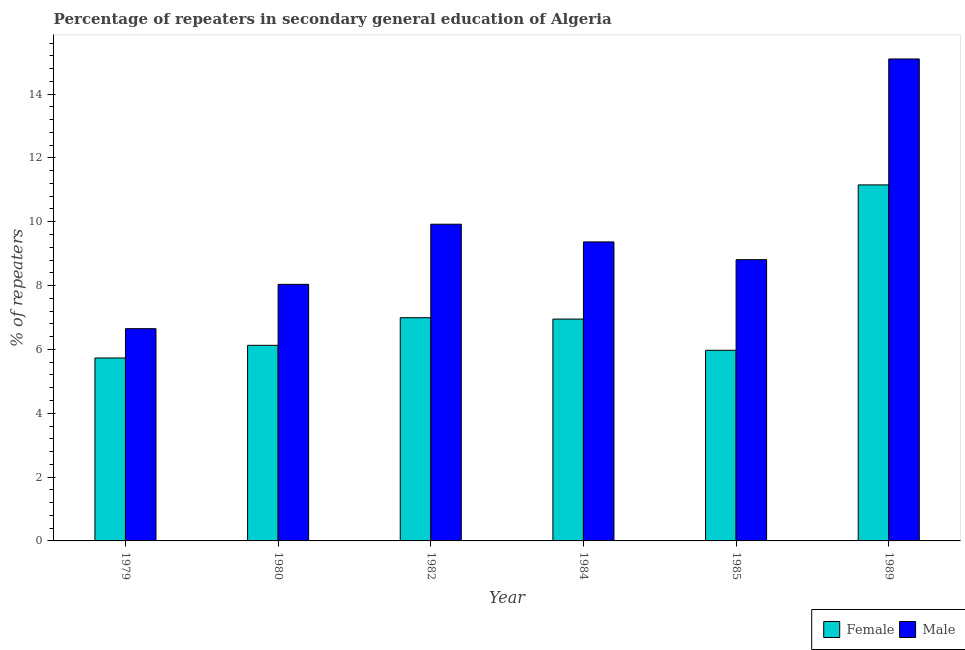How many different coloured bars are there?
Your response must be concise. 2. How many groups of bars are there?
Your answer should be compact. 6. How many bars are there on the 1st tick from the right?
Your response must be concise. 2. What is the label of the 1st group of bars from the left?
Keep it short and to the point. 1979. In how many cases, is the number of bars for a given year not equal to the number of legend labels?
Provide a short and direct response. 0. What is the percentage of female repeaters in 1979?
Provide a succinct answer. 5.73. Across all years, what is the maximum percentage of male repeaters?
Keep it short and to the point. 15.1. Across all years, what is the minimum percentage of female repeaters?
Give a very brief answer. 5.73. In which year was the percentage of female repeaters maximum?
Give a very brief answer. 1989. In which year was the percentage of female repeaters minimum?
Your response must be concise. 1979. What is the total percentage of male repeaters in the graph?
Give a very brief answer. 57.89. What is the difference between the percentage of female repeaters in 1979 and that in 1982?
Keep it short and to the point. -1.26. What is the difference between the percentage of female repeaters in 1984 and the percentage of male repeaters in 1985?
Offer a terse response. 0.98. What is the average percentage of male repeaters per year?
Provide a succinct answer. 9.65. In how many years, is the percentage of male repeaters greater than 8 %?
Give a very brief answer. 5. What is the ratio of the percentage of female repeaters in 1980 to that in 1985?
Your answer should be very brief. 1.03. What is the difference between the highest and the second highest percentage of female repeaters?
Your answer should be very brief. 4.16. What is the difference between the highest and the lowest percentage of male repeaters?
Your answer should be compact. 8.45. Is the sum of the percentage of male repeaters in 1980 and 1982 greater than the maximum percentage of female repeaters across all years?
Keep it short and to the point. Yes. What does the 1st bar from the right in 1985 represents?
Make the answer very short. Male. How many bars are there?
Offer a very short reply. 12. Are all the bars in the graph horizontal?
Your answer should be very brief. No. What is the title of the graph?
Keep it short and to the point. Percentage of repeaters in secondary general education of Algeria. What is the label or title of the X-axis?
Your answer should be very brief. Year. What is the label or title of the Y-axis?
Offer a very short reply. % of repeaters. What is the % of repeaters of Female in 1979?
Offer a terse response. 5.73. What is the % of repeaters in Male in 1979?
Provide a short and direct response. 6.65. What is the % of repeaters in Female in 1980?
Your response must be concise. 6.13. What is the % of repeaters in Male in 1980?
Your answer should be compact. 8.04. What is the % of repeaters in Female in 1982?
Offer a very short reply. 6.99. What is the % of repeaters of Male in 1982?
Provide a short and direct response. 9.92. What is the % of repeaters in Female in 1984?
Give a very brief answer. 6.95. What is the % of repeaters in Male in 1984?
Keep it short and to the point. 9.37. What is the % of repeaters of Female in 1985?
Provide a succinct answer. 5.97. What is the % of repeaters of Male in 1985?
Ensure brevity in your answer.  8.81. What is the % of repeaters of Female in 1989?
Your answer should be compact. 11.15. What is the % of repeaters in Male in 1989?
Your answer should be very brief. 15.1. Across all years, what is the maximum % of repeaters of Female?
Offer a very short reply. 11.15. Across all years, what is the maximum % of repeaters of Male?
Your answer should be compact. 15.1. Across all years, what is the minimum % of repeaters of Female?
Offer a terse response. 5.73. Across all years, what is the minimum % of repeaters of Male?
Your answer should be compact. 6.65. What is the total % of repeaters of Female in the graph?
Make the answer very short. 42.93. What is the total % of repeaters in Male in the graph?
Keep it short and to the point. 57.89. What is the difference between the % of repeaters of Female in 1979 and that in 1980?
Give a very brief answer. -0.4. What is the difference between the % of repeaters in Male in 1979 and that in 1980?
Offer a terse response. -1.39. What is the difference between the % of repeaters of Female in 1979 and that in 1982?
Ensure brevity in your answer.  -1.26. What is the difference between the % of repeaters in Male in 1979 and that in 1982?
Keep it short and to the point. -3.27. What is the difference between the % of repeaters in Female in 1979 and that in 1984?
Give a very brief answer. -1.22. What is the difference between the % of repeaters of Male in 1979 and that in 1984?
Your answer should be compact. -2.72. What is the difference between the % of repeaters in Female in 1979 and that in 1985?
Offer a terse response. -0.24. What is the difference between the % of repeaters of Male in 1979 and that in 1985?
Give a very brief answer. -2.16. What is the difference between the % of repeaters in Female in 1979 and that in 1989?
Provide a short and direct response. -5.42. What is the difference between the % of repeaters in Male in 1979 and that in 1989?
Provide a short and direct response. -8.45. What is the difference between the % of repeaters in Female in 1980 and that in 1982?
Provide a succinct answer. -0.87. What is the difference between the % of repeaters of Male in 1980 and that in 1982?
Your response must be concise. -1.88. What is the difference between the % of repeaters of Female in 1980 and that in 1984?
Your answer should be very brief. -0.82. What is the difference between the % of repeaters of Male in 1980 and that in 1984?
Offer a very short reply. -1.33. What is the difference between the % of repeaters in Female in 1980 and that in 1985?
Your answer should be compact. 0.16. What is the difference between the % of repeaters in Male in 1980 and that in 1985?
Your response must be concise. -0.77. What is the difference between the % of repeaters of Female in 1980 and that in 1989?
Ensure brevity in your answer.  -5.03. What is the difference between the % of repeaters in Male in 1980 and that in 1989?
Your answer should be compact. -7.06. What is the difference between the % of repeaters in Female in 1982 and that in 1984?
Your answer should be compact. 0.04. What is the difference between the % of repeaters of Male in 1982 and that in 1984?
Make the answer very short. 0.55. What is the difference between the % of repeaters of Female in 1982 and that in 1985?
Make the answer very short. 1.02. What is the difference between the % of repeaters of Male in 1982 and that in 1985?
Provide a succinct answer. 1.11. What is the difference between the % of repeaters of Female in 1982 and that in 1989?
Keep it short and to the point. -4.16. What is the difference between the % of repeaters of Male in 1982 and that in 1989?
Offer a terse response. -5.18. What is the difference between the % of repeaters of Female in 1984 and that in 1985?
Provide a short and direct response. 0.98. What is the difference between the % of repeaters of Male in 1984 and that in 1985?
Your answer should be compact. 0.56. What is the difference between the % of repeaters in Female in 1984 and that in 1989?
Offer a very short reply. -4.2. What is the difference between the % of repeaters of Male in 1984 and that in 1989?
Offer a terse response. -5.73. What is the difference between the % of repeaters in Female in 1985 and that in 1989?
Give a very brief answer. -5.18. What is the difference between the % of repeaters in Male in 1985 and that in 1989?
Keep it short and to the point. -6.29. What is the difference between the % of repeaters in Female in 1979 and the % of repeaters in Male in 1980?
Keep it short and to the point. -2.31. What is the difference between the % of repeaters of Female in 1979 and the % of repeaters of Male in 1982?
Your answer should be very brief. -4.19. What is the difference between the % of repeaters in Female in 1979 and the % of repeaters in Male in 1984?
Provide a short and direct response. -3.64. What is the difference between the % of repeaters of Female in 1979 and the % of repeaters of Male in 1985?
Your answer should be very brief. -3.08. What is the difference between the % of repeaters of Female in 1979 and the % of repeaters of Male in 1989?
Your response must be concise. -9.37. What is the difference between the % of repeaters of Female in 1980 and the % of repeaters of Male in 1982?
Provide a succinct answer. -3.79. What is the difference between the % of repeaters in Female in 1980 and the % of repeaters in Male in 1984?
Offer a very short reply. -3.24. What is the difference between the % of repeaters in Female in 1980 and the % of repeaters in Male in 1985?
Make the answer very short. -2.68. What is the difference between the % of repeaters in Female in 1980 and the % of repeaters in Male in 1989?
Ensure brevity in your answer.  -8.97. What is the difference between the % of repeaters of Female in 1982 and the % of repeaters of Male in 1984?
Give a very brief answer. -2.37. What is the difference between the % of repeaters in Female in 1982 and the % of repeaters in Male in 1985?
Your response must be concise. -1.82. What is the difference between the % of repeaters of Female in 1982 and the % of repeaters of Male in 1989?
Provide a short and direct response. -8.11. What is the difference between the % of repeaters of Female in 1984 and the % of repeaters of Male in 1985?
Your answer should be very brief. -1.86. What is the difference between the % of repeaters in Female in 1984 and the % of repeaters in Male in 1989?
Your answer should be very brief. -8.15. What is the difference between the % of repeaters of Female in 1985 and the % of repeaters of Male in 1989?
Ensure brevity in your answer.  -9.13. What is the average % of repeaters of Female per year?
Provide a short and direct response. 7.16. What is the average % of repeaters in Male per year?
Ensure brevity in your answer.  9.65. In the year 1979, what is the difference between the % of repeaters in Female and % of repeaters in Male?
Provide a short and direct response. -0.92. In the year 1980, what is the difference between the % of repeaters in Female and % of repeaters in Male?
Give a very brief answer. -1.91. In the year 1982, what is the difference between the % of repeaters of Female and % of repeaters of Male?
Keep it short and to the point. -2.93. In the year 1984, what is the difference between the % of repeaters of Female and % of repeaters of Male?
Provide a short and direct response. -2.42. In the year 1985, what is the difference between the % of repeaters of Female and % of repeaters of Male?
Keep it short and to the point. -2.84. In the year 1989, what is the difference between the % of repeaters in Female and % of repeaters in Male?
Ensure brevity in your answer.  -3.95. What is the ratio of the % of repeaters in Female in 1979 to that in 1980?
Offer a terse response. 0.94. What is the ratio of the % of repeaters in Male in 1979 to that in 1980?
Make the answer very short. 0.83. What is the ratio of the % of repeaters in Female in 1979 to that in 1982?
Offer a very short reply. 0.82. What is the ratio of the % of repeaters in Male in 1979 to that in 1982?
Keep it short and to the point. 0.67. What is the ratio of the % of repeaters in Female in 1979 to that in 1984?
Your response must be concise. 0.82. What is the ratio of the % of repeaters in Male in 1979 to that in 1984?
Provide a succinct answer. 0.71. What is the ratio of the % of repeaters in Female in 1979 to that in 1985?
Your response must be concise. 0.96. What is the ratio of the % of repeaters in Male in 1979 to that in 1985?
Offer a very short reply. 0.75. What is the ratio of the % of repeaters of Female in 1979 to that in 1989?
Give a very brief answer. 0.51. What is the ratio of the % of repeaters in Male in 1979 to that in 1989?
Keep it short and to the point. 0.44. What is the ratio of the % of repeaters in Female in 1980 to that in 1982?
Provide a short and direct response. 0.88. What is the ratio of the % of repeaters in Male in 1980 to that in 1982?
Your answer should be very brief. 0.81. What is the ratio of the % of repeaters in Female in 1980 to that in 1984?
Give a very brief answer. 0.88. What is the ratio of the % of repeaters of Male in 1980 to that in 1984?
Your answer should be very brief. 0.86. What is the ratio of the % of repeaters in Female in 1980 to that in 1985?
Provide a succinct answer. 1.03. What is the ratio of the % of repeaters of Male in 1980 to that in 1985?
Ensure brevity in your answer.  0.91. What is the ratio of the % of repeaters in Female in 1980 to that in 1989?
Your answer should be very brief. 0.55. What is the ratio of the % of repeaters of Male in 1980 to that in 1989?
Provide a short and direct response. 0.53. What is the ratio of the % of repeaters in Male in 1982 to that in 1984?
Your answer should be compact. 1.06. What is the ratio of the % of repeaters in Female in 1982 to that in 1985?
Give a very brief answer. 1.17. What is the ratio of the % of repeaters of Male in 1982 to that in 1985?
Offer a terse response. 1.13. What is the ratio of the % of repeaters of Female in 1982 to that in 1989?
Give a very brief answer. 0.63. What is the ratio of the % of repeaters in Male in 1982 to that in 1989?
Provide a succinct answer. 0.66. What is the ratio of the % of repeaters in Female in 1984 to that in 1985?
Offer a very short reply. 1.16. What is the ratio of the % of repeaters in Male in 1984 to that in 1985?
Your response must be concise. 1.06. What is the ratio of the % of repeaters of Female in 1984 to that in 1989?
Your answer should be very brief. 0.62. What is the ratio of the % of repeaters of Male in 1984 to that in 1989?
Provide a succinct answer. 0.62. What is the ratio of the % of repeaters in Female in 1985 to that in 1989?
Your answer should be very brief. 0.54. What is the ratio of the % of repeaters in Male in 1985 to that in 1989?
Make the answer very short. 0.58. What is the difference between the highest and the second highest % of repeaters in Female?
Keep it short and to the point. 4.16. What is the difference between the highest and the second highest % of repeaters in Male?
Offer a very short reply. 5.18. What is the difference between the highest and the lowest % of repeaters in Female?
Provide a succinct answer. 5.42. What is the difference between the highest and the lowest % of repeaters in Male?
Your answer should be compact. 8.45. 